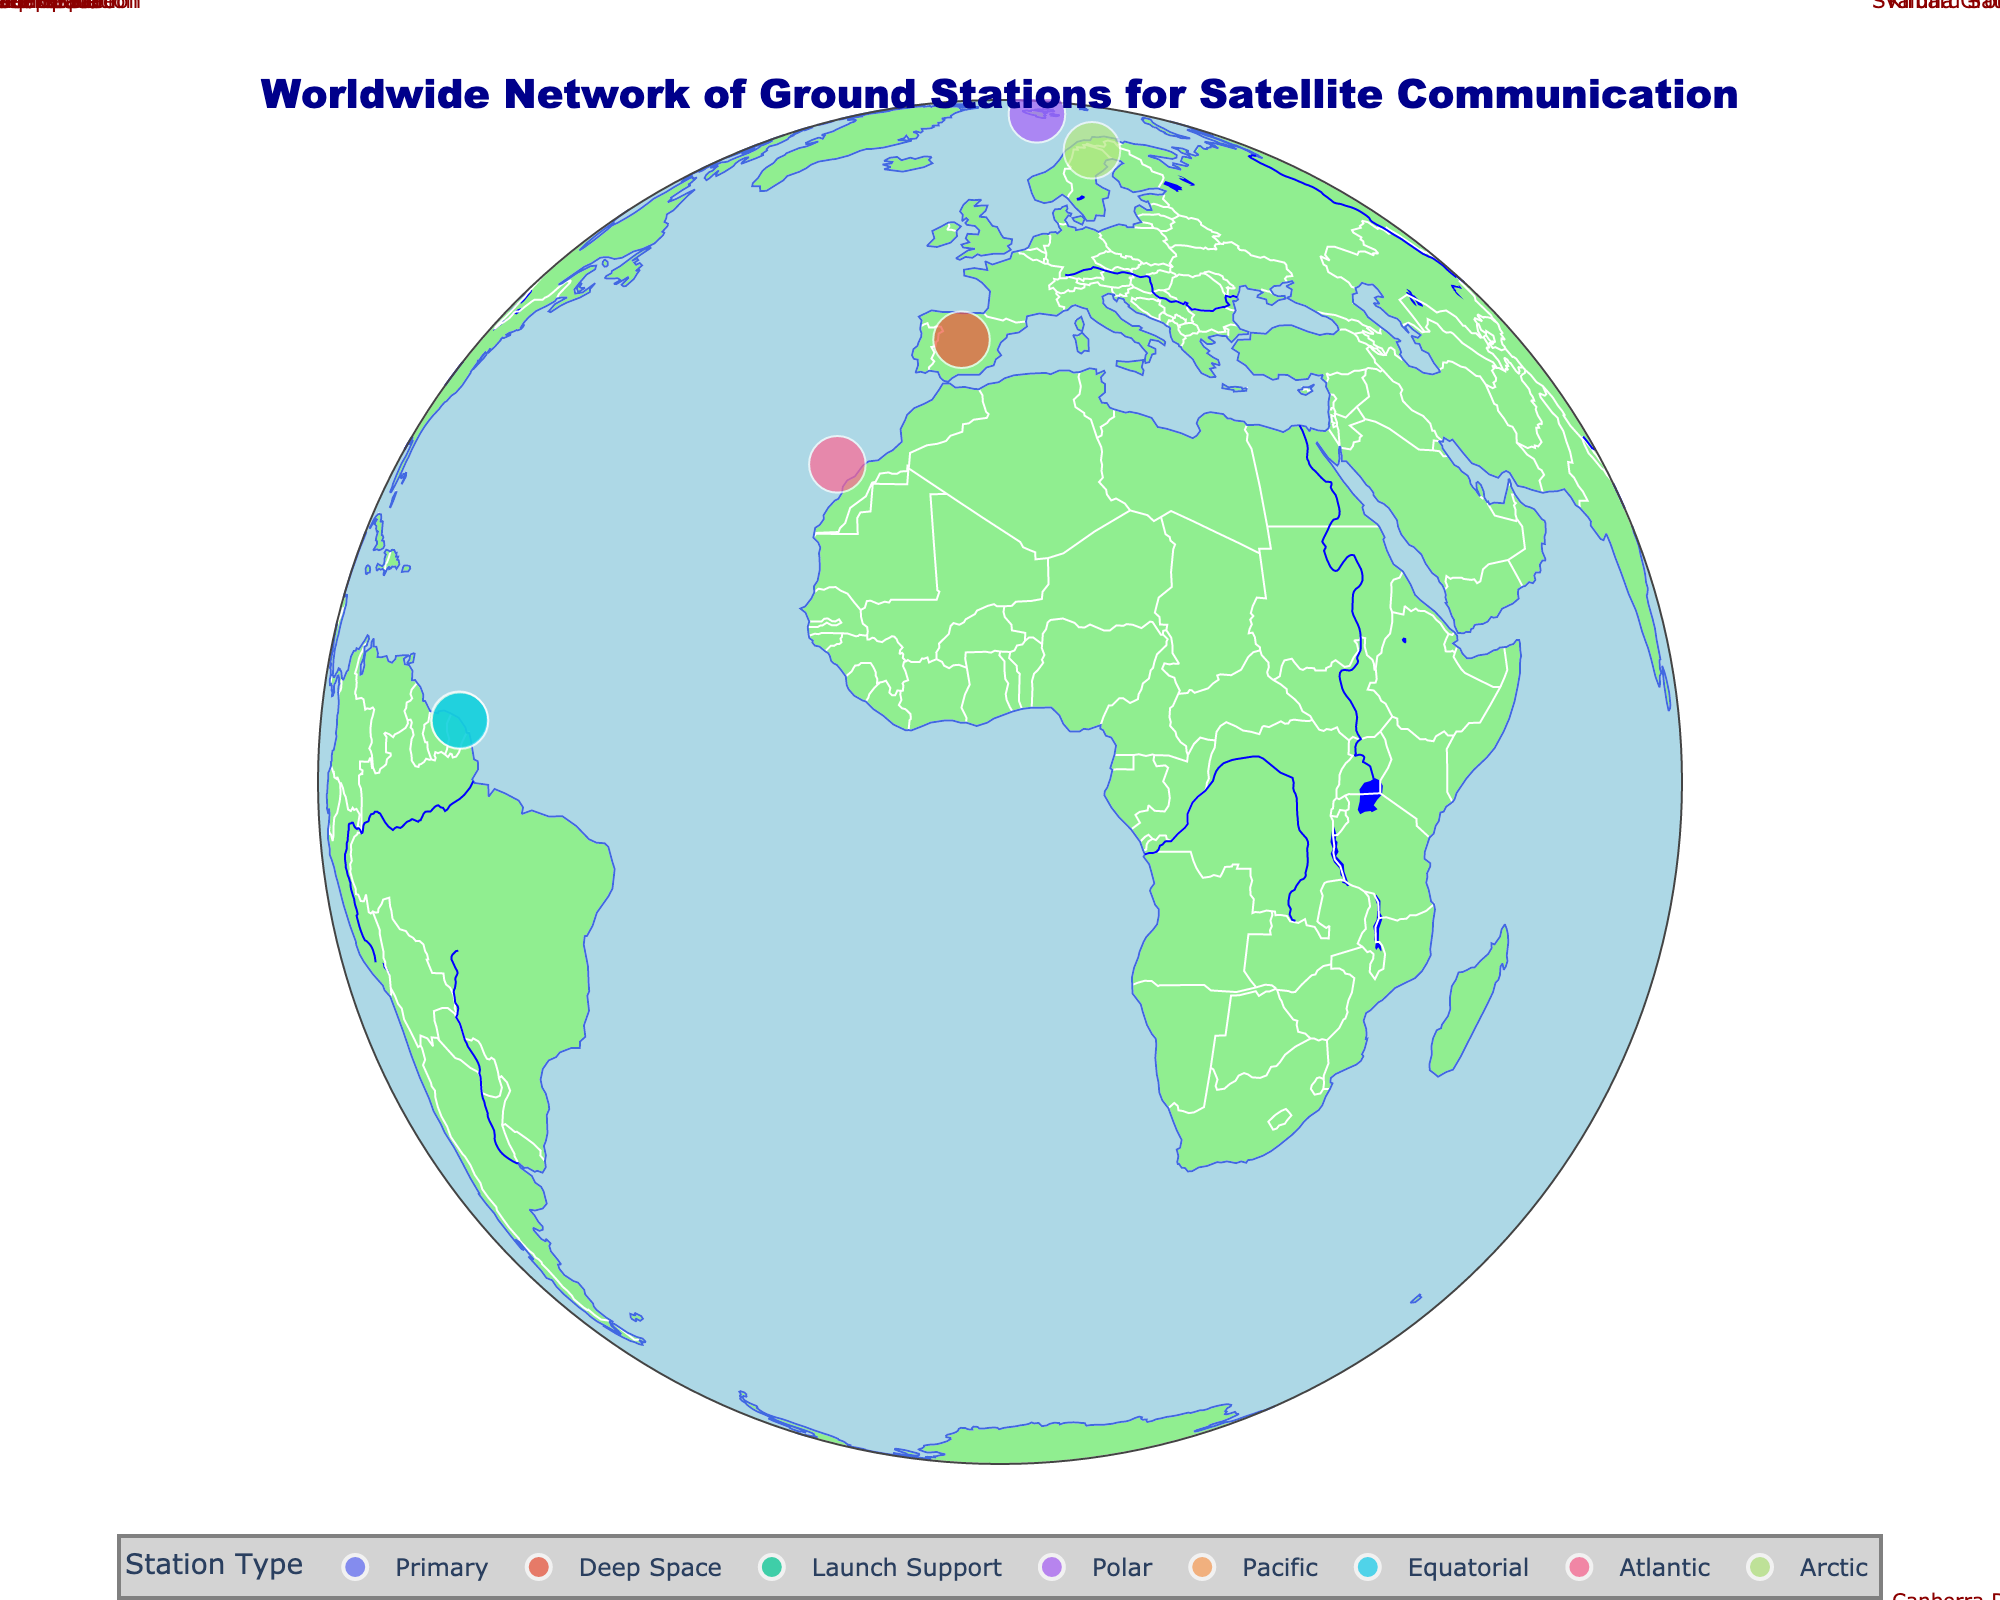What is the title of the plot? The title of the plot is usually found at the top of the figure. In this figure, it is written in a large, dark blue font.
Answer: Worldwide Network of Ground Stations for Satellite Communication How many types of ground stations are there? You can see different colors representing various types of stations in the legend section at the bottom center of the figure. By counting them, you can determine the number of different station types.
Answer: 6 Which ground station is located closest to the equator? Look for the station with a latitude closest to 0. The station near coordinates (latitude 0, longitude 0) is Kourou Ground Station, since its latitude is around 5.1614.
Answer: Kourou Ground Station Which station appears to be supported by SpaceX technology? Refer to the hover data or annotations for specific information about partner technologies. The station supported by SpaceX Starlink Terminal technology is labeled in the figure.
Answer: Houston Mission Control Which station is represented at the most northern latitude? Identify the station with the highest latitude value by looking at the geographic dispersion on the map. The most northern station is Svalbard Satellite Station with a latitude of 78.2297.
Answer: Svalbard Satellite Station Are there more stations in the southern hemisphere or northern hemisphere? Count the number of stations in each hemisphere by comparing their latitudes (positive for northern, negative for southern).
Answer: Northern hemisphere Which station has the least advanced technology displayed on the hover data? Compare the partner technologies listed in the hover information for each station to determine the one that appears less advanced based on the description.
Answer: This is subjective Which launch support station is present in South America? Look for stations labeled as "Launch Support" and locate them on the map by focusing on the South American continent. Guiana Space Center fits this description.
Answer: Guiana Space Center How many deep space ground stations are shown? Check the colors/types for “Deep Space” in the legend and count the corresponding points on the map.
Answer: 3 Which ground station is closest to the geographical location of another station? By visually comparing their positions on the map, identify pairs of stations that appear close to one another, such as Guiana Space Center and Kourou Ground Station.
Answer: Guiana Space Center and Kourou Ground Station 